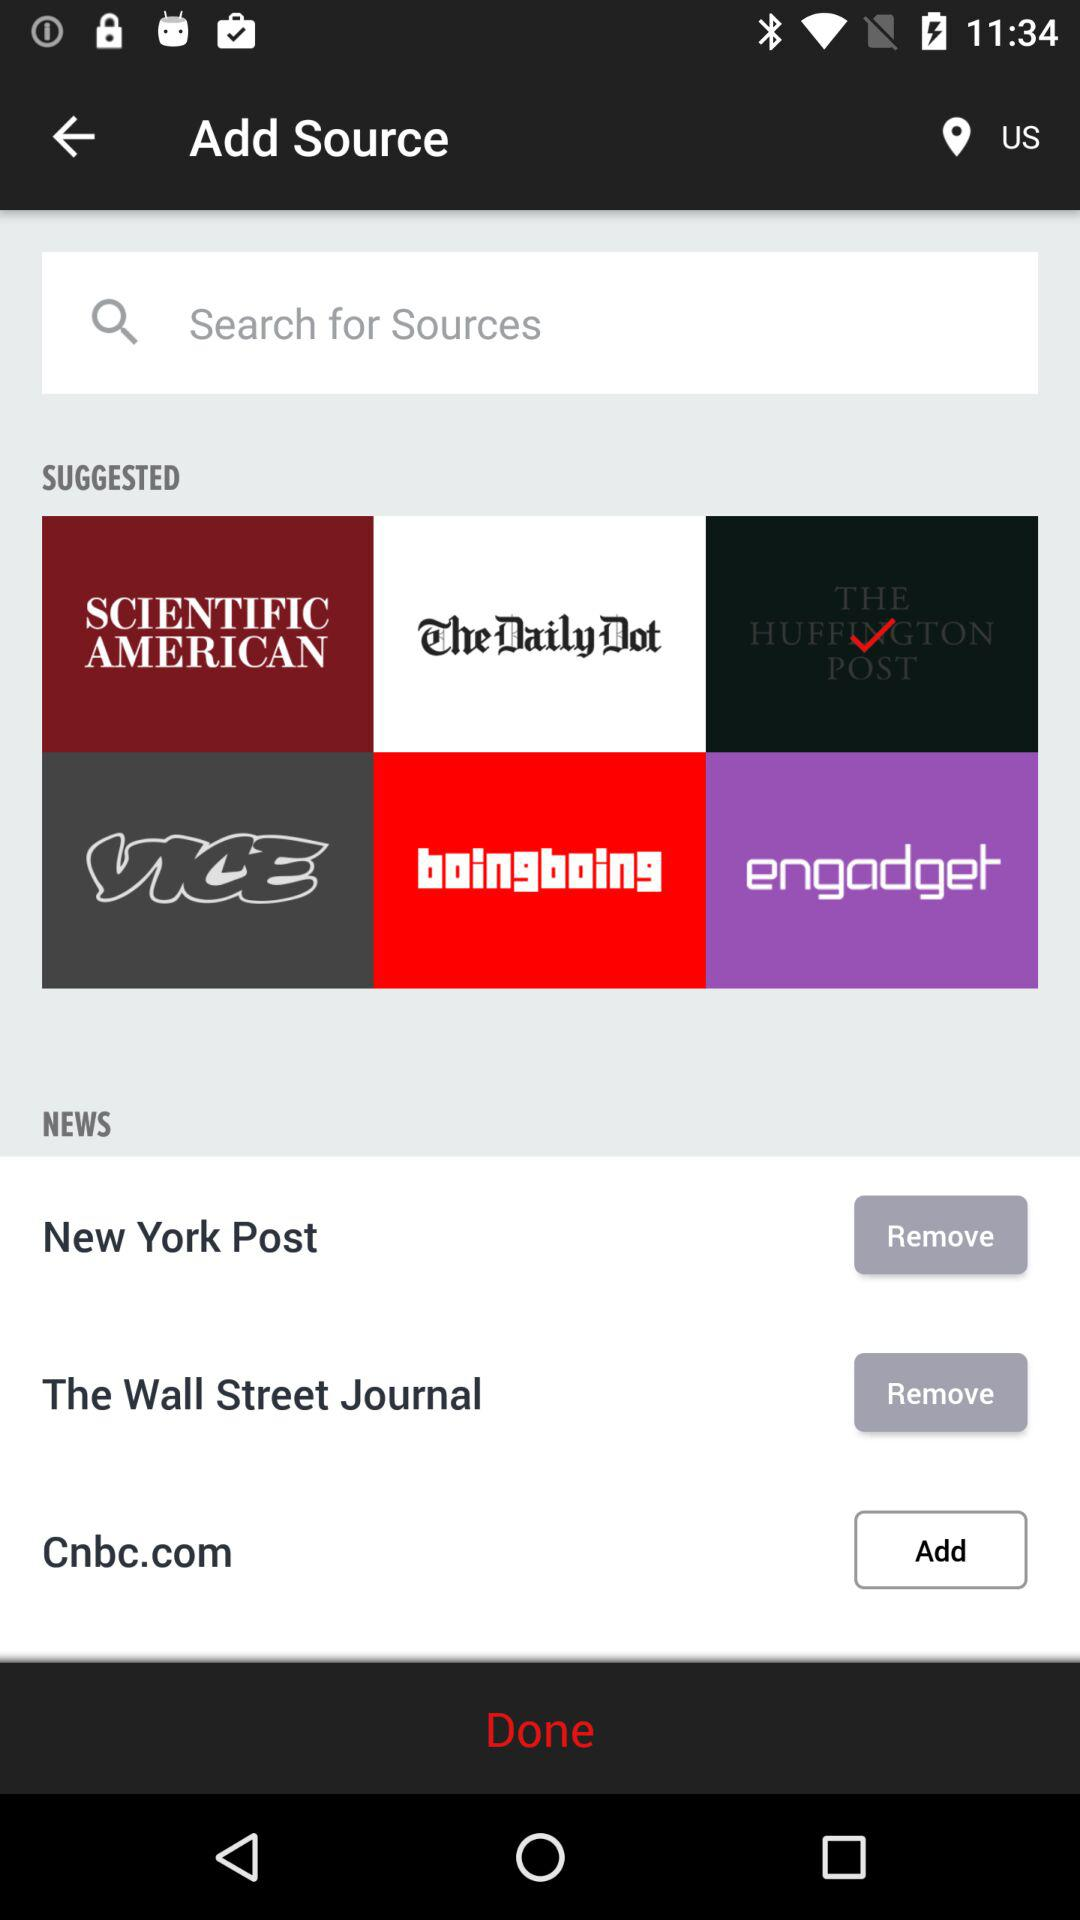What country is mentioned? The mentioned country is the United States. 